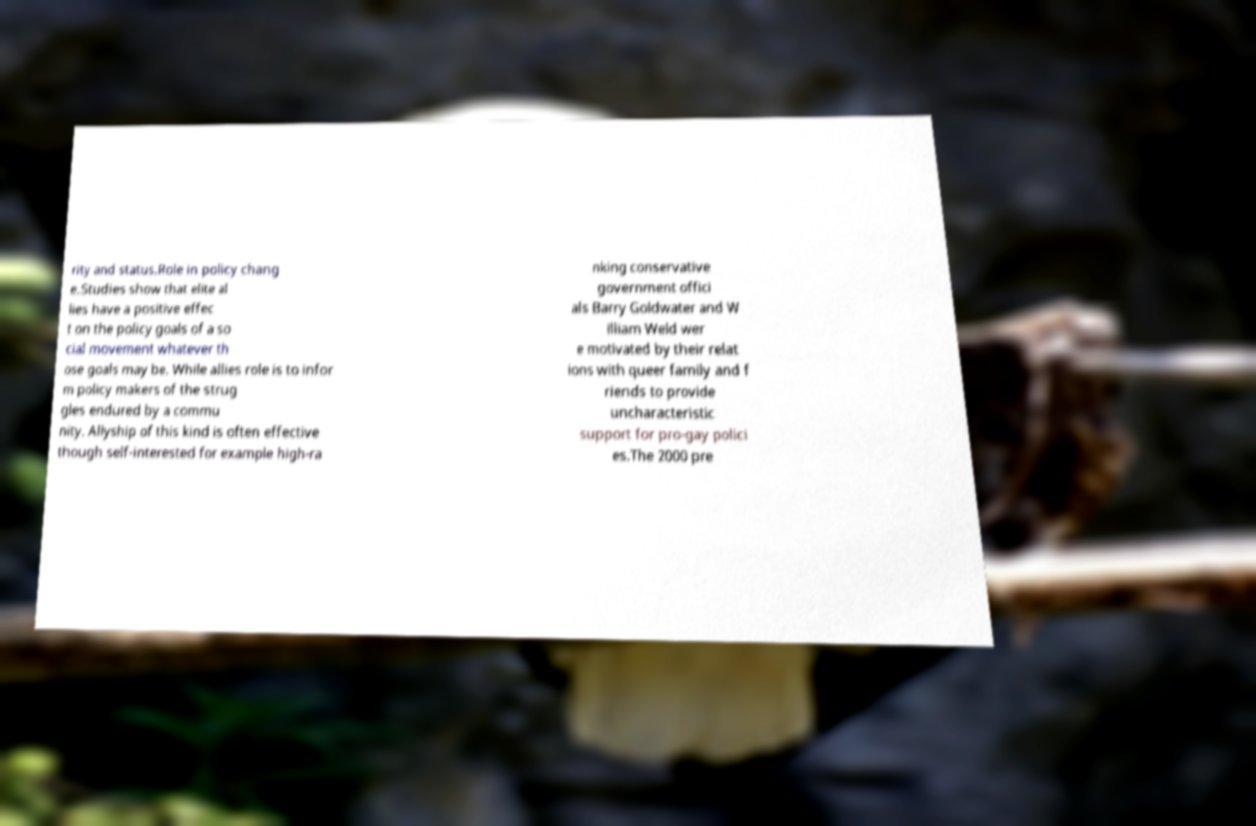Please read and relay the text visible in this image. What does it say? rity and status.Role in policy chang e.Studies show that elite al lies have a positive effec t on the policy goals of a so cial movement whatever th ose goals may be. While allies role is to infor m policy makers of the strug gles endured by a commu nity. Allyship of this kind is often effective though self-interested for example high-ra nking conservative government offici als Barry Goldwater and W illiam Weld wer e motivated by their relat ions with queer family and f riends to provide uncharacteristic support for pro-gay polici es.The 2000 pre 